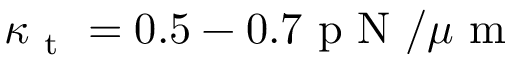<formula> <loc_0><loc_0><loc_500><loc_500>\kappa _ { t } = 0 . 5 - 0 . 7 p N / \mu m</formula> 